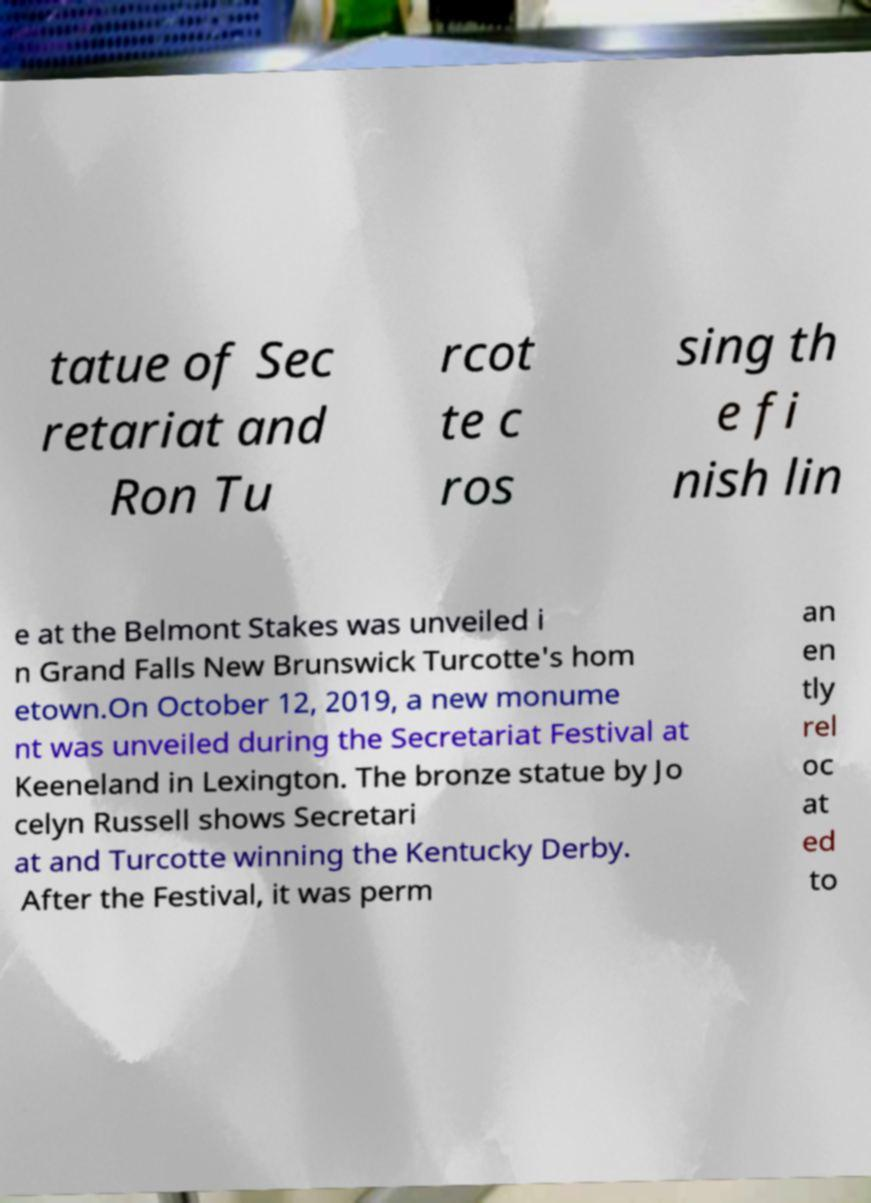I need the written content from this picture converted into text. Can you do that? tatue of Sec retariat and Ron Tu rcot te c ros sing th e fi nish lin e at the Belmont Stakes was unveiled i n Grand Falls New Brunswick Turcotte's hom etown.On October 12, 2019, a new monume nt was unveiled during the Secretariat Festival at Keeneland in Lexington. The bronze statue by Jo celyn Russell shows Secretari at and Turcotte winning the Kentucky Derby. After the Festival, it was perm an en tly rel oc at ed to 